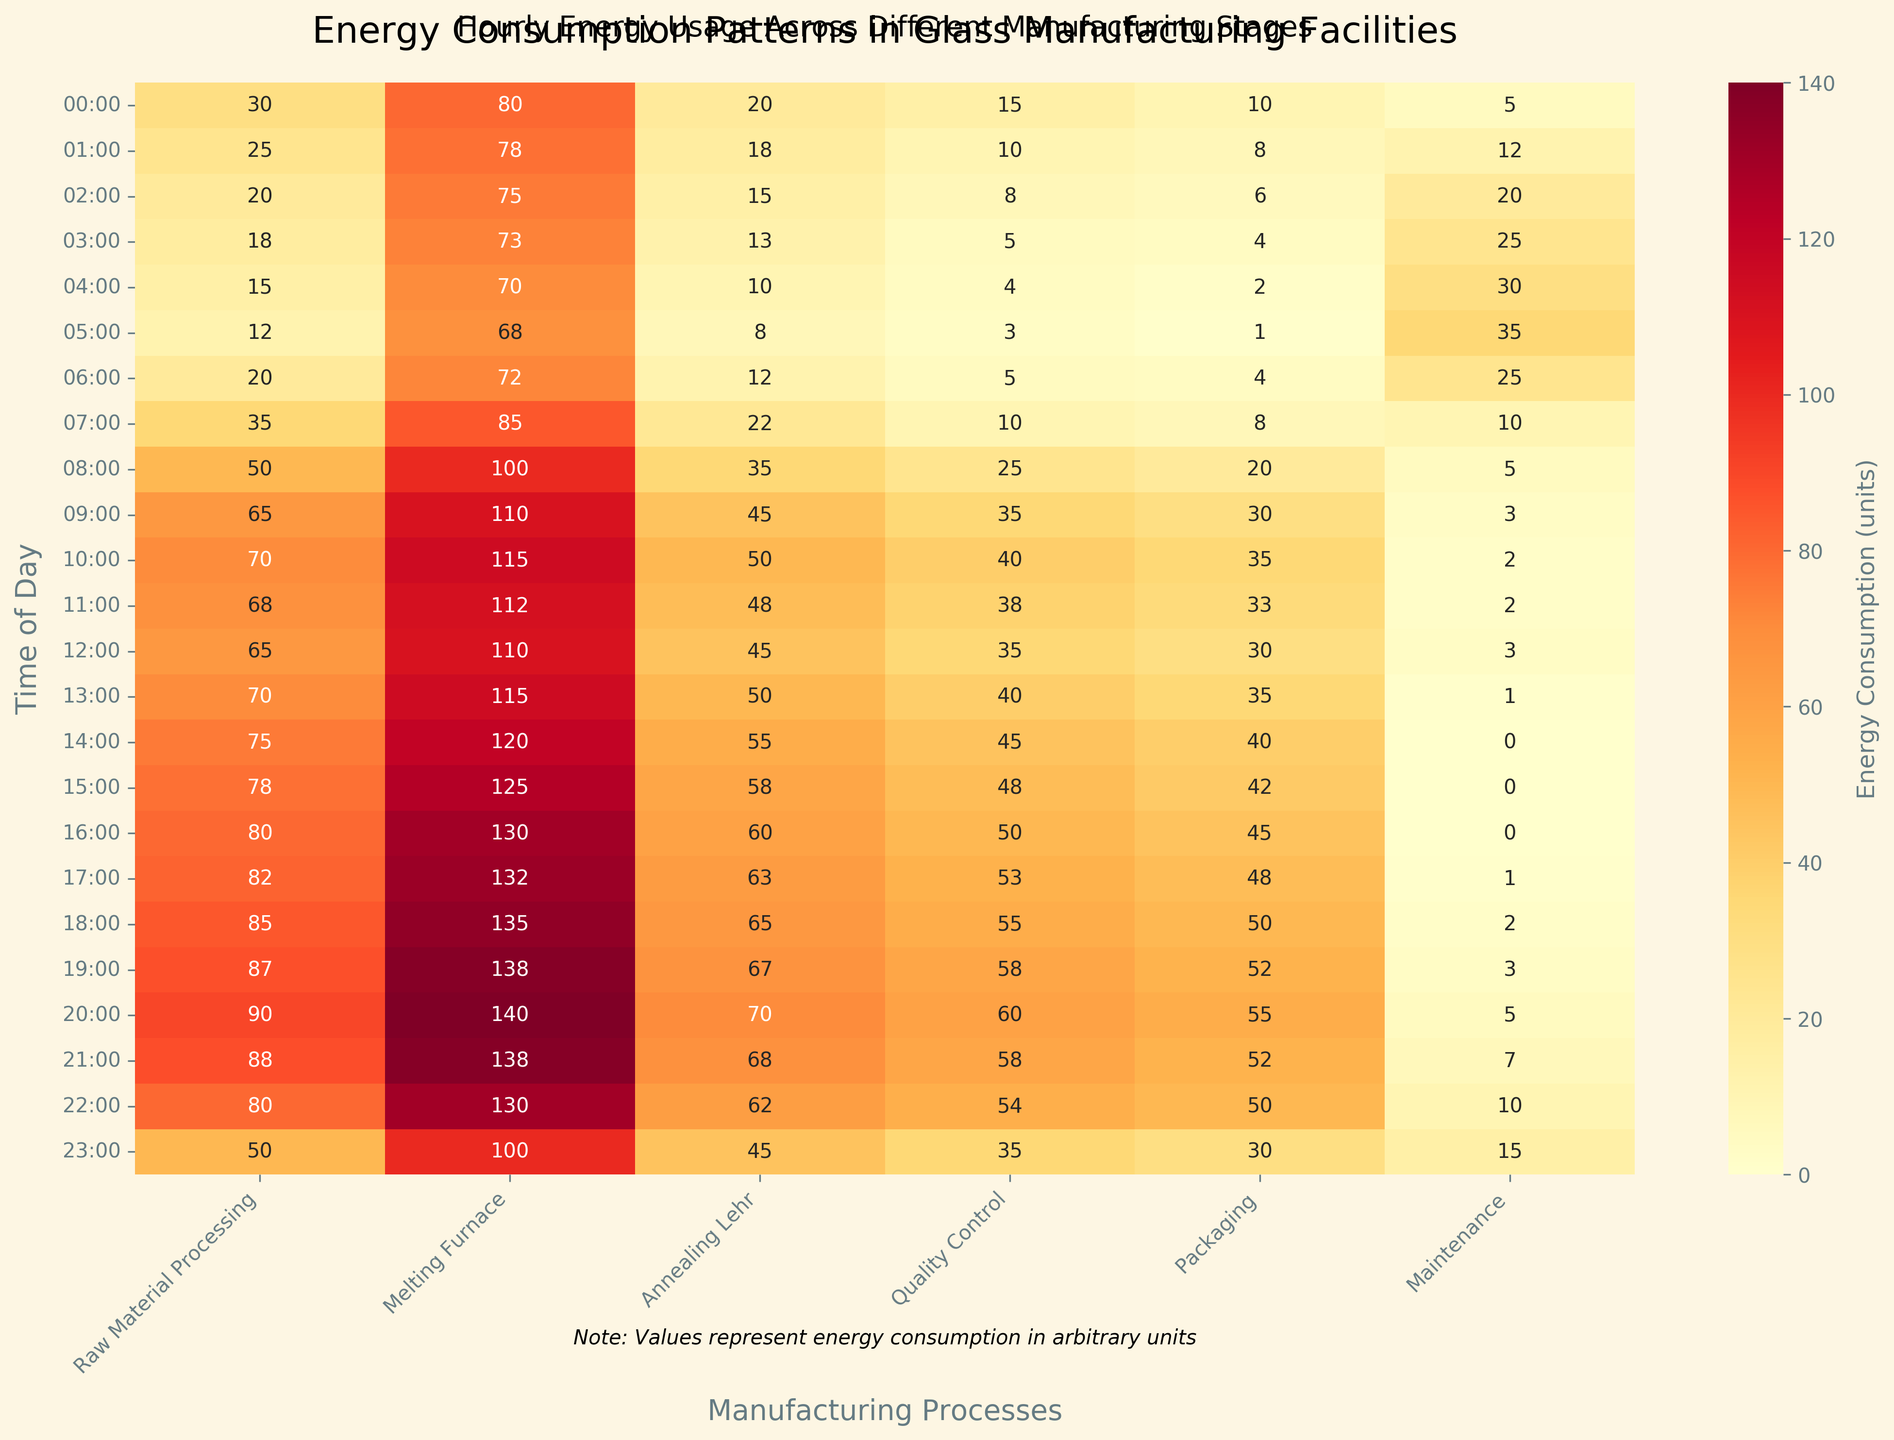What's the title of the heatmap? The title is always prominently placed, usually at the top of the figure. By looking at the top center, we see the title read, "Energy Consumption Patterns in Glass Manufacturing Facilities."
Answer: Energy Consumption Patterns in Glass Manufacturing Facilities What's the time with the highest energy consumption for the Melting Furnace? We need to find the highest value in the "Melting Furnace" column. By checking each value, we see that the highest consumption is at 20:00, which is 140 units.
Answer: 20:00 Between what hours is the energy consumption for Packaging the highest? We look at the "Packaging" column and find the maximum value, which is 55 units. By associating it with the corresponding hour, we see that it occurs at 20:00.
Answer: 20:00 Which manufacturing process has the least energy consumption at 04:00? We need to check all processes in the row corresponding to 04:00. The minimum value in that row is 2, which occurs in the "Quality Control" process.
Answer: Quality Control What's the combined energy consumption for the Melting Furnace and Raw Material Processing at 09:00? First, identify the values for the Melting Furnace (110) and Raw Material Processing (65) at 09:00. Adding these values together gives us 110 + 65 = 175 units.
Answer: 175 units What's the average energy consumption for Annealing Lehr from 00:00 to 05:00? To find the average, sum the energy consumption for Annealing Lehr between 00:00 and 05:00: (20 + 18 + 15 + 13 + 10 + 8) = 84. Now divide by the number of data points (6). The average is 84 / 6 = 14 units.
Answer: 14 units Which manufacturing process experiences the smallest increase in energy consumption from 00:00 to 23:00? Examine the increase from 00:00 to 23:00 for all processes: Raw Material Processing (30 to 50, +20), Melting Furnace (80 to 100, +20), Annealing Lehr (20 to 45, +25), Quality Control (15 to 35, +20), Packaging (10 to 30, +20), Maintenance (5 to 15, +10). The smallest increase is seen in Maintenance (+10 units).
Answer: Maintenance How does the energy consumption for Maintenance change throughout the night (00:00 - 06:00)? Look at the Maintenance values from 00:00 to 06:00: (5, 12, 20, 25, 30, 35). There is a general increasing trend where the energy consumption steadily rises.
Answer: It steadily increases What is the time and process with the highest energy consumption overall? By checking all values in the heatmap, we notice that the maximum energy consumption is 140 units, which occurs in the "Melting Furnace" at 20:00.
Answer: 20:00, Melting Furnace 